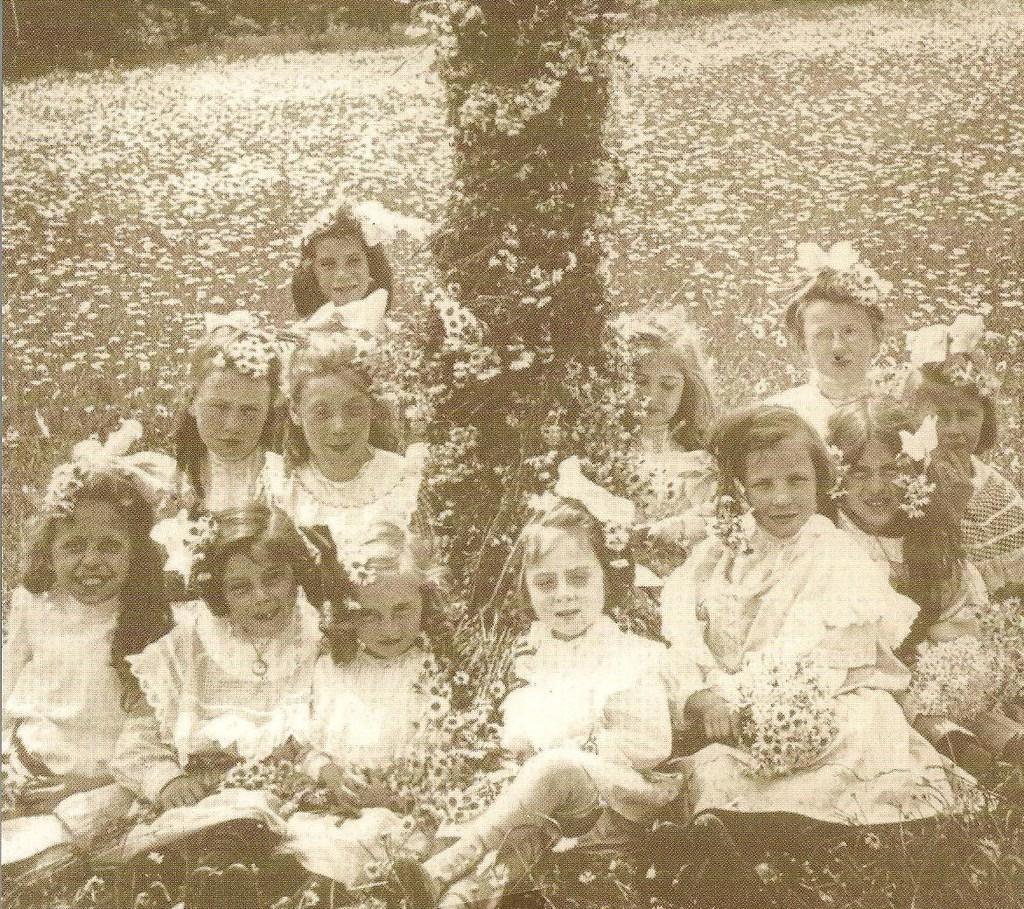Could you give a brief overview of what you see in this image? In this image I can see a group of girls are sitting, they wore white color dresses. It is a black and white image. 